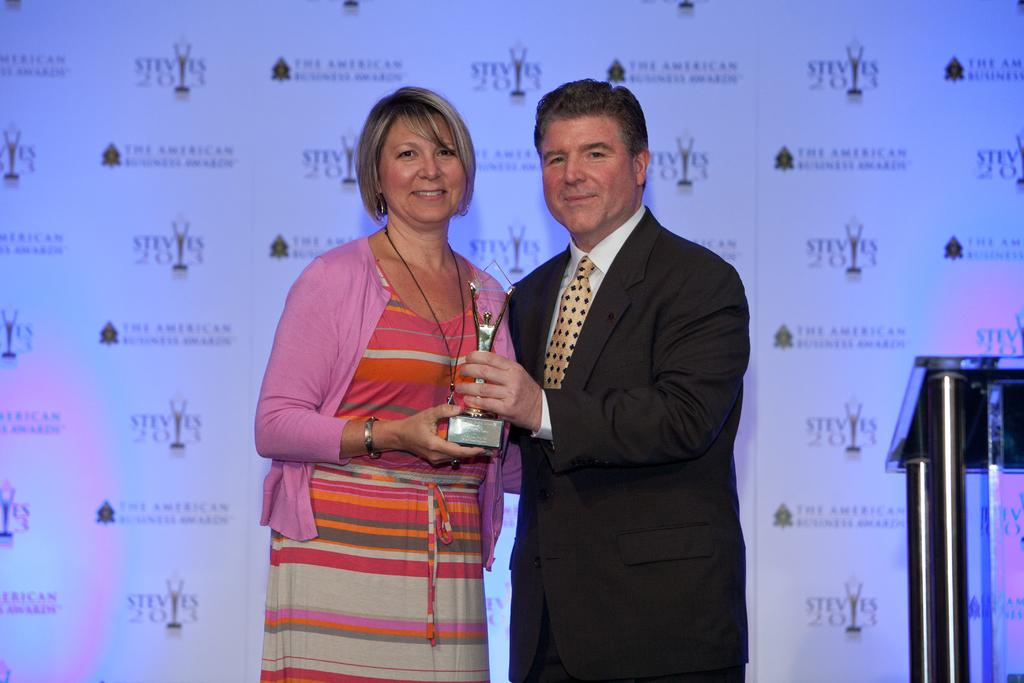How many people are in the image? There are two persons standing in the image. What are the two persons holding? The two persons are holding a trophy. Can you describe the clothing of the person on the right? The person on the right is wearing a black blazer and a white color shirt. What can be seen in the background of the image? There is a banner visible in the background of the image. What type of scarf is the person on the left wearing in the image? There is no scarf visible on either person in the image. How many fans are visible in the image? There are no fans present in the image. 